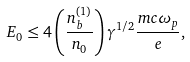Convert formula to latex. <formula><loc_0><loc_0><loc_500><loc_500>E _ { 0 } \leq 4 \left ( \frac { n _ { b } ^ { ( 1 ) } } { n _ { 0 } } \right ) \gamma ^ { 1 / 2 } \frac { m c \omega _ { p } } { e } ,</formula> 